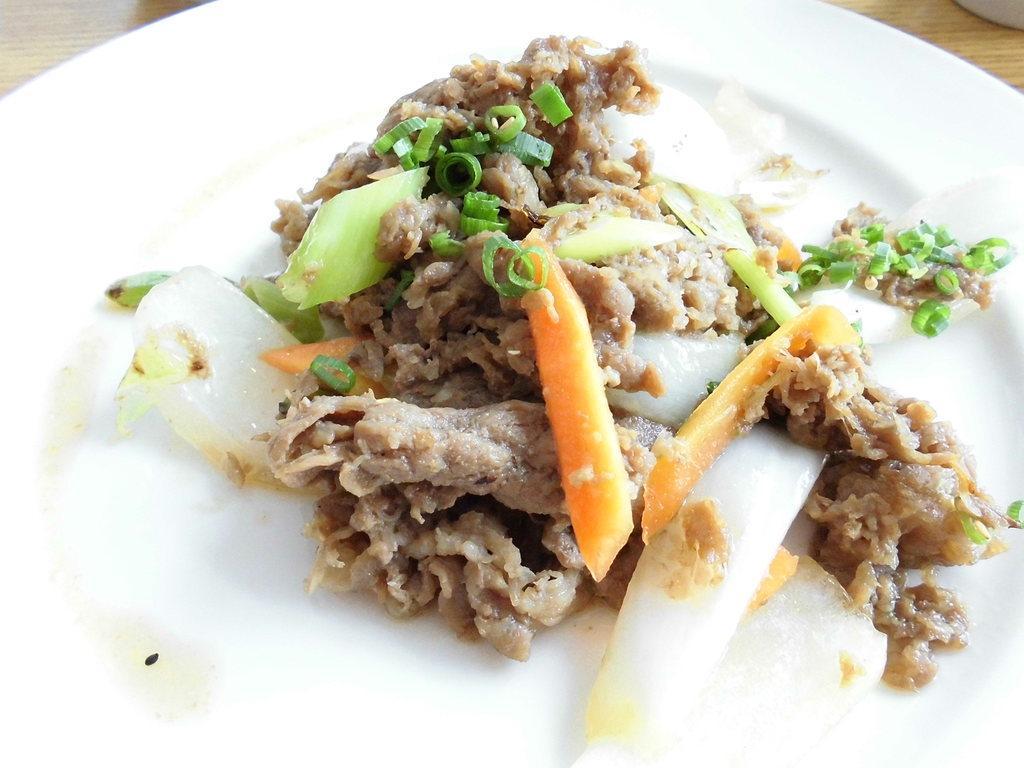Could you give a brief overview of what you see in this image? This is a plate with the food on it. This food is made of carrots, spring onions, few other vegetables and ingredients are added to it. At the top right and left corners of the image, I think this is a wooden table. 